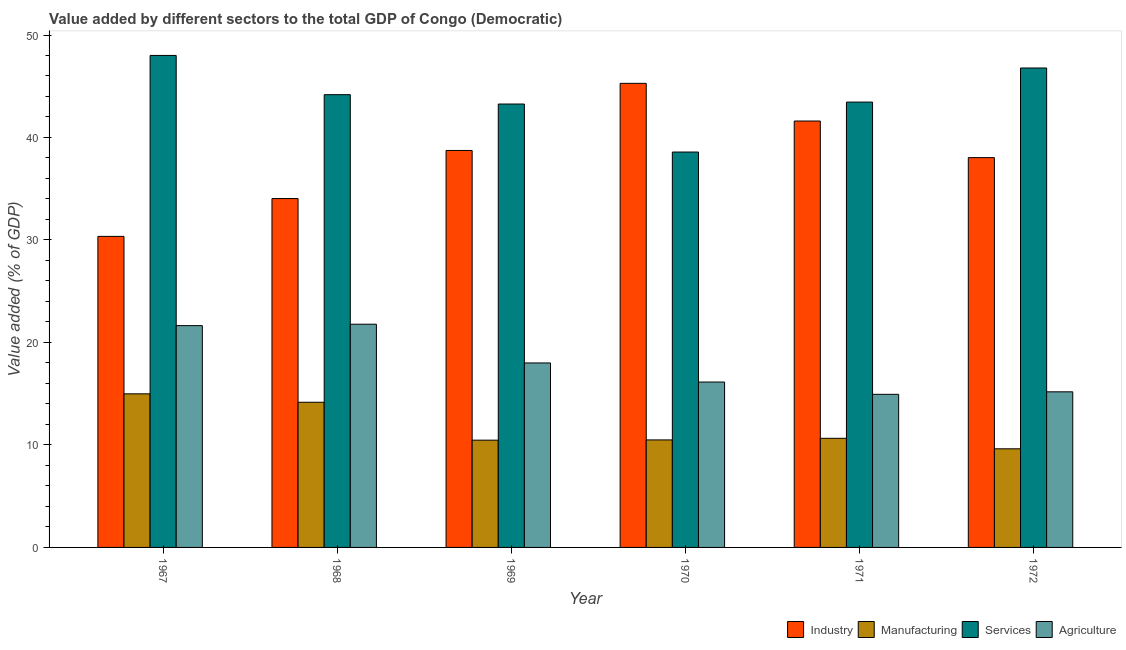How many different coloured bars are there?
Provide a succinct answer. 4. How many groups of bars are there?
Offer a very short reply. 6. Are the number of bars per tick equal to the number of legend labels?
Your answer should be very brief. Yes. Are the number of bars on each tick of the X-axis equal?
Ensure brevity in your answer.  Yes. How many bars are there on the 2nd tick from the right?
Your response must be concise. 4. What is the label of the 1st group of bars from the left?
Make the answer very short. 1967. In how many cases, is the number of bars for a given year not equal to the number of legend labels?
Provide a short and direct response. 0. What is the value added by services sector in 1972?
Your answer should be very brief. 46.78. Across all years, what is the maximum value added by industrial sector?
Make the answer very short. 45.28. Across all years, what is the minimum value added by manufacturing sector?
Offer a terse response. 9.62. In which year was the value added by industrial sector maximum?
Your response must be concise. 1970. In which year was the value added by agricultural sector minimum?
Provide a short and direct response. 1971. What is the total value added by industrial sector in the graph?
Keep it short and to the point. 228.05. What is the difference between the value added by manufacturing sector in 1967 and that in 1972?
Your response must be concise. 5.36. What is the difference between the value added by agricultural sector in 1970 and the value added by services sector in 1968?
Give a very brief answer. -5.64. What is the average value added by industrial sector per year?
Your answer should be very brief. 38.01. In the year 1970, what is the difference between the value added by manufacturing sector and value added by agricultural sector?
Give a very brief answer. 0. In how many years, is the value added by manufacturing sector greater than 8 %?
Keep it short and to the point. 6. What is the ratio of the value added by industrial sector in 1971 to that in 1972?
Provide a short and direct response. 1.09. Is the difference between the value added by services sector in 1968 and 1972 greater than the difference between the value added by agricultural sector in 1968 and 1972?
Make the answer very short. No. What is the difference between the highest and the second highest value added by manufacturing sector?
Your answer should be compact. 0.82. What is the difference between the highest and the lowest value added by manufacturing sector?
Provide a short and direct response. 5.36. In how many years, is the value added by manufacturing sector greater than the average value added by manufacturing sector taken over all years?
Your answer should be compact. 2. What does the 2nd bar from the left in 1970 represents?
Your response must be concise. Manufacturing. What does the 1st bar from the right in 1972 represents?
Keep it short and to the point. Agriculture. Is it the case that in every year, the sum of the value added by industrial sector and value added by manufacturing sector is greater than the value added by services sector?
Keep it short and to the point. No. Are all the bars in the graph horizontal?
Keep it short and to the point. No. How many years are there in the graph?
Provide a succinct answer. 6. Does the graph contain any zero values?
Ensure brevity in your answer.  No. Where does the legend appear in the graph?
Offer a very short reply. Bottom right. How are the legend labels stacked?
Your answer should be very brief. Horizontal. What is the title of the graph?
Your answer should be compact. Value added by different sectors to the total GDP of Congo (Democratic). Does "First 20% of population" appear as one of the legend labels in the graph?
Give a very brief answer. No. What is the label or title of the X-axis?
Offer a terse response. Year. What is the label or title of the Y-axis?
Your response must be concise. Value added (% of GDP). What is the Value added (% of GDP) of Industry in 1967?
Offer a terse response. 30.35. What is the Value added (% of GDP) of Manufacturing in 1967?
Your answer should be compact. 14.99. What is the Value added (% of GDP) in Services in 1967?
Make the answer very short. 48.01. What is the Value added (% of GDP) of Agriculture in 1967?
Provide a short and direct response. 21.64. What is the Value added (% of GDP) in Industry in 1968?
Provide a succinct answer. 34.04. What is the Value added (% of GDP) of Manufacturing in 1968?
Provide a succinct answer. 14.16. What is the Value added (% of GDP) in Services in 1968?
Keep it short and to the point. 44.18. What is the Value added (% of GDP) of Agriculture in 1968?
Your answer should be compact. 21.78. What is the Value added (% of GDP) in Industry in 1969?
Give a very brief answer. 38.73. What is the Value added (% of GDP) in Manufacturing in 1969?
Keep it short and to the point. 10.47. What is the Value added (% of GDP) of Services in 1969?
Your answer should be very brief. 43.27. What is the Value added (% of GDP) of Agriculture in 1969?
Give a very brief answer. 18. What is the Value added (% of GDP) in Industry in 1970?
Ensure brevity in your answer.  45.28. What is the Value added (% of GDP) of Manufacturing in 1970?
Give a very brief answer. 10.49. What is the Value added (% of GDP) in Services in 1970?
Offer a very short reply. 38.58. What is the Value added (% of GDP) of Agriculture in 1970?
Keep it short and to the point. 16.14. What is the Value added (% of GDP) of Industry in 1971?
Keep it short and to the point. 41.61. What is the Value added (% of GDP) in Manufacturing in 1971?
Give a very brief answer. 10.65. What is the Value added (% of GDP) in Services in 1971?
Ensure brevity in your answer.  43.45. What is the Value added (% of GDP) of Agriculture in 1971?
Keep it short and to the point. 14.94. What is the Value added (% of GDP) of Industry in 1972?
Offer a very short reply. 38.04. What is the Value added (% of GDP) in Manufacturing in 1972?
Provide a short and direct response. 9.62. What is the Value added (% of GDP) of Services in 1972?
Your answer should be very brief. 46.78. What is the Value added (% of GDP) in Agriculture in 1972?
Offer a very short reply. 15.18. Across all years, what is the maximum Value added (% of GDP) in Industry?
Make the answer very short. 45.28. Across all years, what is the maximum Value added (% of GDP) of Manufacturing?
Your response must be concise. 14.99. Across all years, what is the maximum Value added (% of GDP) in Services?
Make the answer very short. 48.01. Across all years, what is the maximum Value added (% of GDP) of Agriculture?
Provide a short and direct response. 21.78. Across all years, what is the minimum Value added (% of GDP) in Industry?
Your answer should be compact. 30.35. Across all years, what is the minimum Value added (% of GDP) in Manufacturing?
Make the answer very short. 9.62. Across all years, what is the minimum Value added (% of GDP) in Services?
Provide a short and direct response. 38.58. Across all years, what is the minimum Value added (% of GDP) in Agriculture?
Provide a short and direct response. 14.94. What is the total Value added (% of GDP) of Industry in the graph?
Provide a short and direct response. 228.05. What is the total Value added (% of GDP) in Manufacturing in the graph?
Keep it short and to the point. 70.38. What is the total Value added (% of GDP) in Services in the graph?
Offer a very short reply. 264.27. What is the total Value added (% of GDP) in Agriculture in the graph?
Keep it short and to the point. 107.68. What is the difference between the Value added (% of GDP) in Industry in 1967 and that in 1968?
Provide a succinct answer. -3.69. What is the difference between the Value added (% of GDP) of Manufacturing in 1967 and that in 1968?
Your response must be concise. 0.82. What is the difference between the Value added (% of GDP) in Services in 1967 and that in 1968?
Provide a short and direct response. 3.83. What is the difference between the Value added (% of GDP) of Agriculture in 1967 and that in 1968?
Provide a succinct answer. -0.14. What is the difference between the Value added (% of GDP) of Industry in 1967 and that in 1969?
Give a very brief answer. -8.38. What is the difference between the Value added (% of GDP) of Manufacturing in 1967 and that in 1969?
Ensure brevity in your answer.  4.52. What is the difference between the Value added (% of GDP) of Services in 1967 and that in 1969?
Your answer should be compact. 4.74. What is the difference between the Value added (% of GDP) of Agriculture in 1967 and that in 1969?
Provide a succinct answer. 3.64. What is the difference between the Value added (% of GDP) of Industry in 1967 and that in 1970?
Make the answer very short. -14.93. What is the difference between the Value added (% of GDP) in Manufacturing in 1967 and that in 1970?
Your answer should be very brief. 4.5. What is the difference between the Value added (% of GDP) of Services in 1967 and that in 1970?
Offer a terse response. 9.43. What is the difference between the Value added (% of GDP) of Agriculture in 1967 and that in 1970?
Ensure brevity in your answer.  5.5. What is the difference between the Value added (% of GDP) in Industry in 1967 and that in 1971?
Make the answer very short. -11.26. What is the difference between the Value added (% of GDP) in Manufacturing in 1967 and that in 1971?
Provide a succinct answer. 4.34. What is the difference between the Value added (% of GDP) in Services in 1967 and that in 1971?
Keep it short and to the point. 4.55. What is the difference between the Value added (% of GDP) of Agriculture in 1967 and that in 1971?
Make the answer very short. 6.7. What is the difference between the Value added (% of GDP) in Industry in 1967 and that in 1972?
Your response must be concise. -7.69. What is the difference between the Value added (% of GDP) in Manufacturing in 1967 and that in 1972?
Your answer should be very brief. 5.36. What is the difference between the Value added (% of GDP) in Services in 1967 and that in 1972?
Give a very brief answer. 1.23. What is the difference between the Value added (% of GDP) in Agriculture in 1967 and that in 1972?
Provide a short and direct response. 6.46. What is the difference between the Value added (% of GDP) of Industry in 1968 and that in 1969?
Make the answer very short. -4.69. What is the difference between the Value added (% of GDP) of Manufacturing in 1968 and that in 1969?
Offer a very short reply. 3.7. What is the difference between the Value added (% of GDP) in Services in 1968 and that in 1969?
Keep it short and to the point. 0.91. What is the difference between the Value added (% of GDP) in Agriculture in 1968 and that in 1969?
Offer a very short reply. 3.78. What is the difference between the Value added (% of GDP) of Industry in 1968 and that in 1970?
Provide a succinct answer. -11.24. What is the difference between the Value added (% of GDP) of Manufacturing in 1968 and that in 1970?
Make the answer very short. 3.67. What is the difference between the Value added (% of GDP) of Services in 1968 and that in 1970?
Your answer should be compact. 5.6. What is the difference between the Value added (% of GDP) in Agriculture in 1968 and that in 1970?
Provide a short and direct response. 5.64. What is the difference between the Value added (% of GDP) in Industry in 1968 and that in 1971?
Provide a short and direct response. -7.56. What is the difference between the Value added (% of GDP) of Manufacturing in 1968 and that in 1971?
Keep it short and to the point. 3.52. What is the difference between the Value added (% of GDP) in Services in 1968 and that in 1971?
Ensure brevity in your answer.  0.72. What is the difference between the Value added (% of GDP) in Agriculture in 1968 and that in 1971?
Your answer should be compact. 6.84. What is the difference between the Value added (% of GDP) of Industry in 1968 and that in 1972?
Your response must be concise. -3.99. What is the difference between the Value added (% of GDP) in Manufacturing in 1968 and that in 1972?
Give a very brief answer. 4.54. What is the difference between the Value added (% of GDP) in Services in 1968 and that in 1972?
Make the answer very short. -2.6. What is the difference between the Value added (% of GDP) of Agriculture in 1968 and that in 1972?
Offer a terse response. 6.6. What is the difference between the Value added (% of GDP) in Industry in 1969 and that in 1970?
Give a very brief answer. -6.55. What is the difference between the Value added (% of GDP) of Manufacturing in 1969 and that in 1970?
Offer a very short reply. -0.03. What is the difference between the Value added (% of GDP) in Services in 1969 and that in 1970?
Ensure brevity in your answer.  4.69. What is the difference between the Value added (% of GDP) of Agriculture in 1969 and that in 1970?
Offer a very short reply. 1.86. What is the difference between the Value added (% of GDP) in Industry in 1969 and that in 1971?
Give a very brief answer. -2.87. What is the difference between the Value added (% of GDP) of Manufacturing in 1969 and that in 1971?
Keep it short and to the point. -0.18. What is the difference between the Value added (% of GDP) in Services in 1969 and that in 1971?
Keep it short and to the point. -0.19. What is the difference between the Value added (% of GDP) of Agriculture in 1969 and that in 1971?
Offer a terse response. 3.06. What is the difference between the Value added (% of GDP) of Industry in 1969 and that in 1972?
Offer a terse response. 0.7. What is the difference between the Value added (% of GDP) in Manufacturing in 1969 and that in 1972?
Your response must be concise. 0.84. What is the difference between the Value added (% of GDP) of Services in 1969 and that in 1972?
Ensure brevity in your answer.  -3.52. What is the difference between the Value added (% of GDP) of Agriculture in 1969 and that in 1972?
Offer a very short reply. 2.82. What is the difference between the Value added (% of GDP) of Industry in 1970 and that in 1971?
Your response must be concise. 3.68. What is the difference between the Value added (% of GDP) of Manufacturing in 1970 and that in 1971?
Keep it short and to the point. -0.16. What is the difference between the Value added (% of GDP) of Services in 1970 and that in 1971?
Provide a succinct answer. -4.87. What is the difference between the Value added (% of GDP) in Agriculture in 1970 and that in 1971?
Offer a terse response. 1.2. What is the difference between the Value added (% of GDP) of Industry in 1970 and that in 1972?
Your response must be concise. 7.25. What is the difference between the Value added (% of GDP) in Manufacturing in 1970 and that in 1972?
Make the answer very short. 0.87. What is the difference between the Value added (% of GDP) of Services in 1970 and that in 1972?
Keep it short and to the point. -8.2. What is the difference between the Value added (% of GDP) in Agriculture in 1970 and that in 1972?
Your answer should be very brief. 0.96. What is the difference between the Value added (% of GDP) of Industry in 1971 and that in 1972?
Your answer should be compact. 3.57. What is the difference between the Value added (% of GDP) of Manufacturing in 1971 and that in 1972?
Provide a short and direct response. 1.02. What is the difference between the Value added (% of GDP) in Services in 1971 and that in 1972?
Ensure brevity in your answer.  -3.33. What is the difference between the Value added (% of GDP) of Agriculture in 1971 and that in 1972?
Your answer should be very brief. -0.24. What is the difference between the Value added (% of GDP) in Industry in 1967 and the Value added (% of GDP) in Manufacturing in 1968?
Offer a very short reply. 16.19. What is the difference between the Value added (% of GDP) of Industry in 1967 and the Value added (% of GDP) of Services in 1968?
Offer a terse response. -13.83. What is the difference between the Value added (% of GDP) in Industry in 1967 and the Value added (% of GDP) in Agriculture in 1968?
Ensure brevity in your answer.  8.57. What is the difference between the Value added (% of GDP) of Manufacturing in 1967 and the Value added (% of GDP) of Services in 1968?
Your response must be concise. -29.19. What is the difference between the Value added (% of GDP) of Manufacturing in 1967 and the Value added (% of GDP) of Agriculture in 1968?
Your answer should be very brief. -6.79. What is the difference between the Value added (% of GDP) of Services in 1967 and the Value added (% of GDP) of Agriculture in 1968?
Offer a very short reply. 26.23. What is the difference between the Value added (% of GDP) of Industry in 1967 and the Value added (% of GDP) of Manufacturing in 1969?
Make the answer very short. 19.88. What is the difference between the Value added (% of GDP) of Industry in 1967 and the Value added (% of GDP) of Services in 1969?
Make the answer very short. -12.91. What is the difference between the Value added (% of GDP) of Industry in 1967 and the Value added (% of GDP) of Agriculture in 1969?
Provide a short and direct response. 12.35. What is the difference between the Value added (% of GDP) in Manufacturing in 1967 and the Value added (% of GDP) in Services in 1969?
Your answer should be very brief. -28.28. What is the difference between the Value added (% of GDP) of Manufacturing in 1967 and the Value added (% of GDP) of Agriculture in 1969?
Your answer should be compact. -3.01. What is the difference between the Value added (% of GDP) in Services in 1967 and the Value added (% of GDP) in Agriculture in 1969?
Your answer should be compact. 30.01. What is the difference between the Value added (% of GDP) in Industry in 1967 and the Value added (% of GDP) in Manufacturing in 1970?
Offer a terse response. 19.86. What is the difference between the Value added (% of GDP) of Industry in 1967 and the Value added (% of GDP) of Services in 1970?
Your answer should be compact. -8.23. What is the difference between the Value added (% of GDP) in Industry in 1967 and the Value added (% of GDP) in Agriculture in 1970?
Offer a very short reply. 14.21. What is the difference between the Value added (% of GDP) of Manufacturing in 1967 and the Value added (% of GDP) of Services in 1970?
Make the answer very short. -23.59. What is the difference between the Value added (% of GDP) in Manufacturing in 1967 and the Value added (% of GDP) in Agriculture in 1970?
Your answer should be compact. -1.15. What is the difference between the Value added (% of GDP) in Services in 1967 and the Value added (% of GDP) in Agriculture in 1970?
Keep it short and to the point. 31.87. What is the difference between the Value added (% of GDP) in Industry in 1967 and the Value added (% of GDP) in Manufacturing in 1971?
Give a very brief answer. 19.7. What is the difference between the Value added (% of GDP) of Industry in 1967 and the Value added (% of GDP) of Services in 1971?
Offer a terse response. -13.1. What is the difference between the Value added (% of GDP) of Industry in 1967 and the Value added (% of GDP) of Agriculture in 1971?
Make the answer very short. 15.41. What is the difference between the Value added (% of GDP) in Manufacturing in 1967 and the Value added (% of GDP) in Services in 1971?
Make the answer very short. -28.47. What is the difference between the Value added (% of GDP) of Manufacturing in 1967 and the Value added (% of GDP) of Agriculture in 1971?
Your answer should be very brief. 0.05. What is the difference between the Value added (% of GDP) in Services in 1967 and the Value added (% of GDP) in Agriculture in 1971?
Make the answer very short. 33.07. What is the difference between the Value added (% of GDP) of Industry in 1967 and the Value added (% of GDP) of Manufacturing in 1972?
Your response must be concise. 20.73. What is the difference between the Value added (% of GDP) in Industry in 1967 and the Value added (% of GDP) in Services in 1972?
Offer a very short reply. -16.43. What is the difference between the Value added (% of GDP) of Industry in 1967 and the Value added (% of GDP) of Agriculture in 1972?
Your answer should be compact. 15.17. What is the difference between the Value added (% of GDP) in Manufacturing in 1967 and the Value added (% of GDP) in Services in 1972?
Give a very brief answer. -31.79. What is the difference between the Value added (% of GDP) of Manufacturing in 1967 and the Value added (% of GDP) of Agriculture in 1972?
Keep it short and to the point. -0.2. What is the difference between the Value added (% of GDP) of Services in 1967 and the Value added (% of GDP) of Agriculture in 1972?
Give a very brief answer. 32.82. What is the difference between the Value added (% of GDP) in Industry in 1968 and the Value added (% of GDP) in Manufacturing in 1969?
Provide a short and direct response. 23.58. What is the difference between the Value added (% of GDP) of Industry in 1968 and the Value added (% of GDP) of Services in 1969?
Offer a terse response. -9.22. What is the difference between the Value added (% of GDP) in Industry in 1968 and the Value added (% of GDP) in Agriculture in 1969?
Give a very brief answer. 16.04. What is the difference between the Value added (% of GDP) in Manufacturing in 1968 and the Value added (% of GDP) in Services in 1969?
Keep it short and to the point. -29.1. What is the difference between the Value added (% of GDP) of Manufacturing in 1968 and the Value added (% of GDP) of Agriculture in 1969?
Make the answer very short. -3.84. What is the difference between the Value added (% of GDP) of Services in 1968 and the Value added (% of GDP) of Agriculture in 1969?
Ensure brevity in your answer.  26.18. What is the difference between the Value added (% of GDP) of Industry in 1968 and the Value added (% of GDP) of Manufacturing in 1970?
Provide a short and direct response. 23.55. What is the difference between the Value added (% of GDP) of Industry in 1968 and the Value added (% of GDP) of Services in 1970?
Provide a succinct answer. -4.54. What is the difference between the Value added (% of GDP) of Industry in 1968 and the Value added (% of GDP) of Agriculture in 1970?
Offer a terse response. 17.9. What is the difference between the Value added (% of GDP) of Manufacturing in 1968 and the Value added (% of GDP) of Services in 1970?
Ensure brevity in your answer.  -24.42. What is the difference between the Value added (% of GDP) of Manufacturing in 1968 and the Value added (% of GDP) of Agriculture in 1970?
Ensure brevity in your answer.  -1.97. What is the difference between the Value added (% of GDP) of Services in 1968 and the Value added (% of GDP) of Agriculture in 1970?
Keep it short and to the point. 28.04. What is the difference between the Value added (% of GDP) of Industry in 1968 and the Value added (% of GDP) of Manufacturing in 1971?
Provide a short and direct response. 23.39. What is the difference between the Value added (% of GDP) in Industry in 1968 and the Value added (% of GDP) in Services in 1971?
Make the answer very short. -9.41. What is the difference between the Value added (% of GDP) of Industry in 1968 and the Value added (% of GDP) of Agriculture in 1971?
Provide a succinct answer. 19.1. What is the difference between the Value added (% of GDP) of Manufacturing in 1968 and the Value added (% of GDP) of Services in 1971?
Give a very brief answer. -29.29. What is the difference between the Value added (% of GDP) of Manufacturing in 1968 and the Value added (% of GDP) of Agriculture in 1971?
Provide a short and direct response. -0.78. What is the difference between the Value added (% of GDP) of Services in 1968 and the Value added (% of GDP) of Agriculture in 1971?
Provide a short and direct response. 29.24. What is the difference between the Value added (% of GDP) of Industry in 1968 and the Value added (% of GDP) of Manufacturing in 1972?
Provide a short and direct response. 24.42. What is the difference between the Value added (% of GDP) of Industry in 1968 and the Value added (% of GDP) of Services in 1972?
Provide a short and direct response. -12.74. What is the difference between the Value added (% of GDP) of Industry in 1968 and the Value added (% of GDP) of Agriculture in 1972?
Provide a succinct answer. 18.86. What is the difference between the Value added (% of GDP) in Manufacturing in 1968 and the Value added (% of GDP) in Services in 1972?
Provide a succinct answer. -32.62. What is the difference between the Value added (% of GDP) in Manufacturing in 1968 and the Value added (% of GDP) in Agriculture in 1972?
Keep it short and to the point. -1.02. What is the difference between the Value added (% of GDP) of Services in 1968 and the Value added (% of GDP) of Agriculture in 1972?
Make the answer very short. 28.99. What is the difference between the Value added (% of GDP) of Industry in 1969 and the Value added (% of GDP) of Manufacturing in 1970?
Offer a terse response. 28.24. What is the difference between the Value added (% of GDP) in Industry in 1969 and the Value added (% of GDP) in Services in 1970?
Your answer should be very brief. 0.15. What is the difference between the Value added (% of GDP) in Industry in 1969 and the Value added (% of GDP) in Agriculture in 1970?
Give a very brief answer. 22.6. What is the difference between the Value added (% of GDP) of Manufacturing in 1969 and the Value added (% of GDP) of Services in 1970?
Your answer should be compact. -28.11. What is the difference between the Value added (% of GDP) in Manufacturing in 1969 and the Value added (% of GDP) in Agriculture in 1970?
Give a very brief answer. -5.67. What is the difference between the Value added (% of GDP) of Services in 1969 and the Value added (% of GDP) of Agriculture in 1970?
Your answer should be very brief. 27.13. What is the difference between the Value added (% of GDP) in Industry in 1969 and the Value added (% of GDP) in Manufacturing in 1971?
Make the answer very short. 28.09. What is the difference between the Value added (% of GDP) of Industry in 1969 and the Value added (% of GDP) of Services in 1971?
Provide a short and direct response. -4.72. What is the difference between the Value added (% of GDP) of Industry in 1969 and the Value added (% of GDP) of Agriculture in 1971?
Provide a short and direct response. 23.79. What is the difference between the Value added (% of GDP) of Manufacturing in 1969 and the Value added (% of GDP) of Services in 1971?
Offer a terse response. -32.99. What is the difference between the Value added (% of GDP) of Manufacturing in 1969 and the Value added (% of GDP) of Agriculture in 1971?
Give a very brief answer. -4.47. What is the difference between the Value added (% of GDP) in Services in 1969 and the Value added (% of GDP) in Agriculture in 1971?
Your answer should be very brief. 28.33. What is the difference between the Value added (% of GDP) of Industry in 1969 and the Value added (% of GDP) of Manufacturing in 1972?
Provide a short and direct response. 29.11. What is the difference between the Value added (% of GDP) in Industry in 1969 and the Value added (% of GDP) in Services in 1972?
Ensure brevity in your answer.  -8.05. What is the difference between the Value added (% of GDP) in Industry in 1969 and the Value added (% of GDP) in Agriculture in 1972?
Your answer should be compact. 23.55. What is the difference between the Value added (% of GDP) of Manufacturing in 1969 and the Value added (% of GDP) of Services in 1972?
Your answer should be very brief. -36.32. What is the difference between the Value added (% of GDP) in Manufacturing in 1969 and the Value added (% of GDP) in Agriculture in 1972?
Offer a very short reply. -4.72. What is the difference between the Value added (% of GDP) in Services in 1969 and the Value added (% of GDP) in Agriculture in 1972?
Keep it short and to the point. 28.08. What is the difference between the Value added (% of GDP) of Industry in 1970 and the Value added (% of GDP) of Manufacturing in 1971?
Offer a terse response. 34.63. What is the difference between the Value added (% of GDP) in Industry in 1970 and the Value added (% of GDP) in Services in 1971?
Keep it short and to the point. 1.83. What is the difference between the Value added (% of GDP) of Industry in 1970 and the Value added (% of GDP) of Agriculture in 1971?
Your response must be concise. 30.34. What is the difference between the Value added (% of GDP) of Manufacturing in 1970 and the Value added (% of GDP) of Services in 1971?
Offer a terse response. -32.96. What is the difference between the Value added (% of GDP) in Manufacturing in 1970 and the Value added (% of GDP) in Agriculture in 1971?
Your answer should be very brief. -4.45. What is the difference between the Value added (% of GDP) in Services in 1970 and the Value added (% of GDP) in Agriculture in 1971?
Provide a succinct answer. 23.64. What is the difference between the Value added (% of GDP) of Industry in 1970 and the Value added (% of GDP) of Manufacturing in 1972?
Offer a very short reply. 35.66. What is the difference between the Value added (% of GDP) of Industry in 1970 and the Value added (% of GDP) of Services in 1972?
Provide a succinct answer. -1.5. What is the difference between the Value added (% of GDP) of Industry in 1970 and the Value added (% of GDP) of Agriculture in 1972?
Your answer should be compact. 30.1. What is the difference between the Value added (% of GDP) of Manufacturing in 1970 and the Value added (% of GDP) of Services in 1972?
Ensure brevity in your answer.  -36.29. What is the difference between the Value added (% of GDP) in Manufacturing in 1970 and the Value added (% of GDP) in Agriculture in 1972?
Offer a very short reply. -4.69. What is the difference between the Value added (% of GDP) of Services in 1970 and the Value added (% of GDP) of Agriculture in 1972?
Give a very brief answer. 23.4. What is the difference between the Value added (% of GDP) of Industry in 1971 and the Value added (% of GDP) of Manufacturing in 1972?
Ensure brevity in your answer.  31.98. What is the difference between the Value added (% of GDP) of Industry in 1971 and the Value added (% of GDP) of Services in 1972?
Make the answer very short. -5.17. What is the difference between the Value added (% of GDP) in Industry in 1971 and the Value added (% of GDP) in Agriculture in 1972?
Provide a succinct answer. 26.42. What is the difference between the Value added (% of GDP) in Manufacturing in 1971 and the Value added (% of GDP) in Services in 1972?
Keep it short and to the point. -36.13. What is the difference between the Value added (% of GDP) in Manufacturing in 1971 and the Value added (% of GDP) in Agriculture in 1972?
Your response must be concise. -4.53. What is the difference between the Value added (% of GDP) of Services in 1971 and the Value added (% of GDP) of Agriculture in 1972?
Provide a succinct answer. 28.27. What is the average Value added (% of GDP) in Industry per year?
Keep it short and to the point. 38.01. What is the average Value added (% of GDP) of Manufacturing per year?
Offer a very short reply. 11.73. What is the average Value added (% of GDP) in Services per year?
Provide a short and direct response. 44.04. What is the average Value added (% of GDP) of Agriculture per year?
Give a very brief answer. 17.95. In the year 1967, what is the difference between the Value added (% of GDP) of Industry and Value added (% of GDP) of Manufacturing?
Offer a terse response. 15.36. In the year 1967, what is the difference between the Value added (% of GDP) of Industry and Value added (% of GDP) of Services?
Give a very brief answer. -17.66. In the year 1967, what is the difference between the Value added (% of GDP) of Industry and Value added (% of GDP) of Agriculture?
Provide a short and direct response. 8.71. In the year 1967, what is the difference between the Value added (% of GDP) in Manufacturing and Value added (% of GDP) in Services?
Provide a succinct answer. -33.02. In the year 1967, what is the difference between the Value added (% of GDP) of Manufacturing and Value added (% of GDP) of Agriculture?
Keep it short and to the point. -6.66. In the year 1967, what is the difference between the Value added (% of GDP) of Services and Value added (% of GDP) of Agriculture?
Offer a terse response. 26.36. In the year 1968, what is the difference between the Value added (% of GDP) in Industry and Value added (% of GDP) in Manufacturing?
Provide a short and direct response. 19.88. In the year 1968, what is the difference between the Value added (% of GDP) of Industry and Value added (% of GDP) of Services?
Give a very brief answer. -10.14. In the year 1968, what is the difference between the Value added (% of GDP) in Industry and Value added (% of GDP) in Agriculture?
Your answer should be very brief. 12.26. In the year 1968, what is the difference between the Value added (% of GDP) of Manufacturing and Value added (% of GDP) of Services?
Offer a very short reply. -30.01. In the year 1968, what is the difference between the Value added (% of GDP) of Manufacturing and Value added (% of GDP) of Agriculture?
Offer a terse response. -7.62. In the year 1968, what is the difference between the Value added (% of GDP) in Services and Value added (% of GDP) in Agriculture?
Make the answer very short. 22.4. In the year 1969, what is the difference between the Value added (% of GDP) in Industry and Value added (% of GDP) in Manufacturing?
Your response must be concise. 28.27. In the year 1969, what is the difference between the Value added (% of GDP) of Industry and Value added (% of GDP) of Services?
Make the answer very short. -4.53. In the year 1969, what is the difference between the Value added (% of GDP) in Industry and Value added (% of GDP) in Agriculture?
Your response must be concise. 20.73. In the year 1969, what is the difference between the Value added (% of GDP) of Manufacturing and Value added (% of GDP) of Services?
Ensure brevity in your answer.  -32.8. In the year 1969, what is the difference between the Value added (% of GDP) in Manufacturing and Value added (% of GDP) in Agriculture?
Your response must be concise. -7.54. In the year 1969, what is the difference between the Value added (% of GDP) in Services and Value added (% of GDP) in Agriculture?
Give a very brief answer. 25.26. In the year 1970, what is the difference between the Value added (% of GDP) of Industry and Value added (% of GDP) of Manufacturing?
Ensure brevity in your answer.  34.79. In the year 1970, what is the difference between the Value added (% of GDP) of Industry and Value added (% of GDP) of Services?
Your response must be concise. 6.7. In the year 1970, what is the difference between the Value added (% of GDP) in Industry and Value added (% of GDP) in Agriculture?
Your answer should be compact. 29.14. In the year 1970, what is the difference between the Value added (% of GDP) of Manufacturing and Value added (% of GDP) of Services?
Keep it short and to the point. -28.09. In the year 1970, what is the difference between the Value added (% of GDP) of Manufacturing and Value added (% of GDP) of Agriculture?
Provide a short and direct response. -5.65. In the year 1970, what is the difference between the Value added (% of GDP) in Services and Value added (% of GDP) in Agriculture?
Ensure brevity in your answer.  22.44. In the year 1971, what is the difference between the Value added (% of GDP) of Industry and Value added (% of GDP) of Manufacturing?
Provide a short and direct response. 30.96. In the year 1971, what is the difference between the Value added (% of GDP) in Industry and Value added (% of GDP) in Services?
Provide a succinct answer. -1.85. In the year 1971, what is the difference between the Value added (% of GDP) of Industry and Value added (% of GDP) of Agriculture?
Offer a terse response. 26.67. In the year 1971, what is the difference between the Value added (% of GDP) in Manufacturing and Value added (% of GDP) in Services?
Keep it short and to the point. -32.81. In the year 1971, what is the difference between the Value added (% of GDP) of Manufacturing and Value added (% of GDP) of Agriculture?
Your response must be concise. -4.29. In the year 1971, what is the difference between the Value added (% of GDP) in Services and Value added (% of GDP) in Agriculture?
Your answer should be very brief. 28.52. In the year 1972, what is the difference between the Value added (% of GDP) in Industry and Value added (% of GDP) in Manufacturing?
Provide a short and direct response. 28.41. In the year 1972, what is the difference between the Value added (% of GDP) of Industry and Value added (% of GDP) of Services?
Provide a succinct answer. -8.74. In the year 1972, what is the difference between the Value added (% of GDP) of Industry and Value added (% of GDP) of Agriculture?
Your response must be concise. 22.85. In the year 1972, what is the difference between the Value added (% of GDP) of Manufacturing and Value added (% of GDP) of Services?
Provide a succinct answer. -37.16. In the year 1972, what is the difference between the Value added (% of GDP) in Manufacturing and Value added (% of GDP) in Agriculture?
Give a very brief answer. -5.56. In the year 1972, what is the difference between the Value added (% of GDP) in Services and Value added (% of GDP) in Agriculture?
Your answer should be compact. 31.6. What is the ratio of the Value added (% of GDP) in Industry in 1967 to that in 1968?
Offer a very short reply. 0.89. What is the ratio of the Value added (% of GDP) in Manufacturing in 1967 to that in 1968?
Make the answer very short. 1.06. What is the ratio of the Value added (% of GDP) of Services in 1967 to that in 1968?
Keep it short and to the point. 1.09. What is the ratio of the Value added (% of GDP) of Industry in 1967 to that in 1969?
Your answer should be compact. 0.78. What is the ratio of the Value added (% of GDP) of Manufacturing in 1967 to that in 1969?
Provide a succinct answer. 1.43. What is the ratio of the Value added (% of GDP) in Services in 1967 to that in 1969?
Provide a short and direct response. 1.11. What is the ratio of the Value added (% of GDP) of Agriculture in 1967 to that in 1969?
Offer a very short reply. 1.2. What is the ratio of the Value added (% of GDP) in Industry in 1967 to that in 1970?
Offer a very short reply. 0.67. What is the ratio of the Value added (% of GDP) of Manufacturing in 1967 to that in 1970?
Your answer should be very brief. 1.43. What is the ratio of the Value added (% of GDP) of Services in 1967 to that in 1970?
Provide a succinct answer. 1.24. What is the ratio of the Value added (% of GDP) of Agriculture in 1967 to that in 1970?
Give a very brief answer. 1.34. What is the ratio of the Value added (% of GDP) in Industry in 1967 to that in 1971?
Offer a terse response. 0.73. What is the ratio of the Value added (% of GDP) in Manufacturing in 1967 to that in 1971?
Your answer should be compact. 1.41. What is the ratio of the Value added (% of GDP) of Services in 1967 to that in 1971?
Keep it short and to the point. 1.1. What is the ratio of the Value added (% of GDP) of Agriculture in 1967 to that in 1971?
Give a very brief answer. 1.45. What is the ratio of the Value added (% of GDP) in Industry in 1967 to that in 1972?
Ensure brevity in your answer.  0.8. What is the ratio of the Value added (% of GDP) of Manufacturing in 1967 to that in 1972?
Your answer should be compact. 1.56. What is the ratio of the Value added (% of GDP) of Services in 1967 to that in 1972?
Your answer should be compact. 1.03. What is the ratio of the Value added (% of GDP) in Agriculture in 1967 to that in 1972?
Provide a succinct answer. 1.43. What is the ratio of the Value added (% of GDP) of Industry in 1968 to that in 1969?
Offer a very short reply. 0.88. What is the ratio of the Value added (% of GDP) in Manufacturing in 1968 to that in 1969?
Provide a short and direct response. 1.35. What is the ratio of the Value added (% of GDP) of Services in 1968 to that in 1969?
Your response must be concise. 1.02. What is the ratio of the Value added (% of GDP) of Agriculture in 1968 to that in 1969?
Provide a succinct answer. 1.21. What is the ratio of the Value added (% of GDP) in Industry in 1968 to that in 1970?
Your answer should be compact. 0.75. What is the ratio of the Value added (% of GDP) of Manufacturing in 1968 to that in 1970?
Your answer should be very brief. 1.35. What is the ratio of the Value added (% of GDP) of Services in 1968 to that in 1970?
Ensure brevity in your answer.  1.15. What is the ratio of the Value added (% of GDP) of Agriculture in 1968 to that in 1970?
Provide a short and direct response. 1.35. What is the ratio of the Value added (% of GDP) of Industry in 1968 to that in 1971?
Give a very brief answer. 0.82. What is the ratio of the Value added (% of GDP) in Manufacturing in 1968 to that in 1971?
Ensure brevity in your answer.  1.33. What is the ratio of the Value added (% of GDP) of Services in 1968 to that in 1971?
Keep it short and to the point. 1.02. What is the ratio of the Value added (% of GDP) in Agriculture in 1968 to that in 1971?
Keep it short and to the point. 1.46. What is the ratio of the Value added (% of GDP) in Industry in 1968 to that in 1972?
Your answer should be compact. 0.9. What is the ratio of the Value added (% of GDP) of Manufacturing in 1968 to that in 1972?
Your answer should be very brief. 1.47. What is the ratio of the Value added (% of GDP) in Services in 1968 to that in 1972?
Keep it short and to the point. 0.94. What is the ratio of the Value added (% of GDP) in Agriculture in 1968 to that in 1972?
Provide a succinct answer. 1.43. What is the ratio of the Value added (% of GDP) of Industry in 1969 to that in 1970?
Ensure brevity in your answer.  0.86. What is the ratio of the Value added (% of GDP) in Services in 1969 to that in 1970?
Give a very brief answer. 1.12. What is the ratio of the Value added (% of GDP) of Agriculture in 1969 to that in 1970?
Offer a very short reply. 1.12. What is the ratio of the Value added (% of GDP) in Industry in 1969 to that in 1971?
Give a very brief answer. 0.93. What is the ratio of the Value added (% of GDP) in Manufacturing in 1969 to that in 1971?
Give a very brief answer. 0.98. What is the ratio of the Value added (% of GDP) in Agriculture in 1969 to that in 1971?
Keep it short and to the point. 1.21. What is the ratio of the Value added (% of GDP) of Industry in 1969 to that in 1972?
Offer a terse response. 1.02. What is the ratio of the Value added (% of GDP) of Manufacturing in 1969 to that in 1972?
Your response must be concise. 1.09. What is the ratio of the Value added (% of GDP) in Services in 1969 to that in 1972?
Your answer should be very brief. 0.92. What is the ratio of the Value added (% of GDP) in Agriculture in 1969 to that in 1972?
Provide a succinct answer. 1.19. What is the ratio of the Value added (% of GDP) of Industry in 1970 to that in 1971?
Your response must be concise. 1.09. What is the ratio of the Value added (% of GDP) of Services in 1970 to that in 1971?
Keep it short and to the point. 0.89. What is the ratio of the Value added (% of GDP) in Agriculture in 1970 to that in 1971?
Offer a very short reply. 1.08. What is the ratio of the Value added (% of GDP) in Industry in 1970 to that in 1972?
Your response must be concise. 1.19. What is the ratio of the Value added (% of GDP) in Manufacturing in 1970 to that in 1972?
Offer a very short reply. 1.09. What is the ratio of the Value added (% of GDP) of Services in 1970 to that in 1972?
Offer a terse response. 0.82. What is the ratio of the Value added (% of GDP) in Agriculture in 1970 to that in 1972?
Your answer should be very brief. 1.06. What is the ratio of the Value added (% of GDP) in Industry in 1971 to that in 1972?
Your answer should be very brief. 1.09. What is the ratio of the Value added (% of GDP) in Manufacturing in 1971 to that in 1972?
Give a very brief answer. 1.11. What is the ratio of the Value added (% of GDP) in Services in 1971 to that in 1972?
Your response must be concise. 0.93. What is the ratio of the Value added (% of GDP) in Agriculture in 1971 to that in 1972?
Provide a succinct answer. 0.98. What is the difference between the highest and the second highest Value added (% of GDP) of Industry?
Your answer should be very brief. 3.68. What is the difference between the highest and the second highest Value added (% of GDP) of Manufacturing?
Provide a succinct answer. 0.82. What is the difference between the highest and the second highest Value added (% of GDP) of Services?
Keep it short and to the point. 1.23. What is the difference between the highest and the second highest Value added (% of GDP) in Agriculture?
Offer a very short reply. 0.14. What is the difference between the highest and the lowest Value added (% of GDP) of Industry?
Give a very brief answer. 14.93. What is the difference between the highest and the lowest Value added (% of GDP) in Manufacturing?
Make the answer very short. 5.36. What is the difference between the highest and the lowest Value added (% of GDP) of Services?
Make the answer very short. 9.43. What is the difference between the highest and the lowest Value added (% of GDP) in Agriculture?
Offer a very short reply. 6.84. 